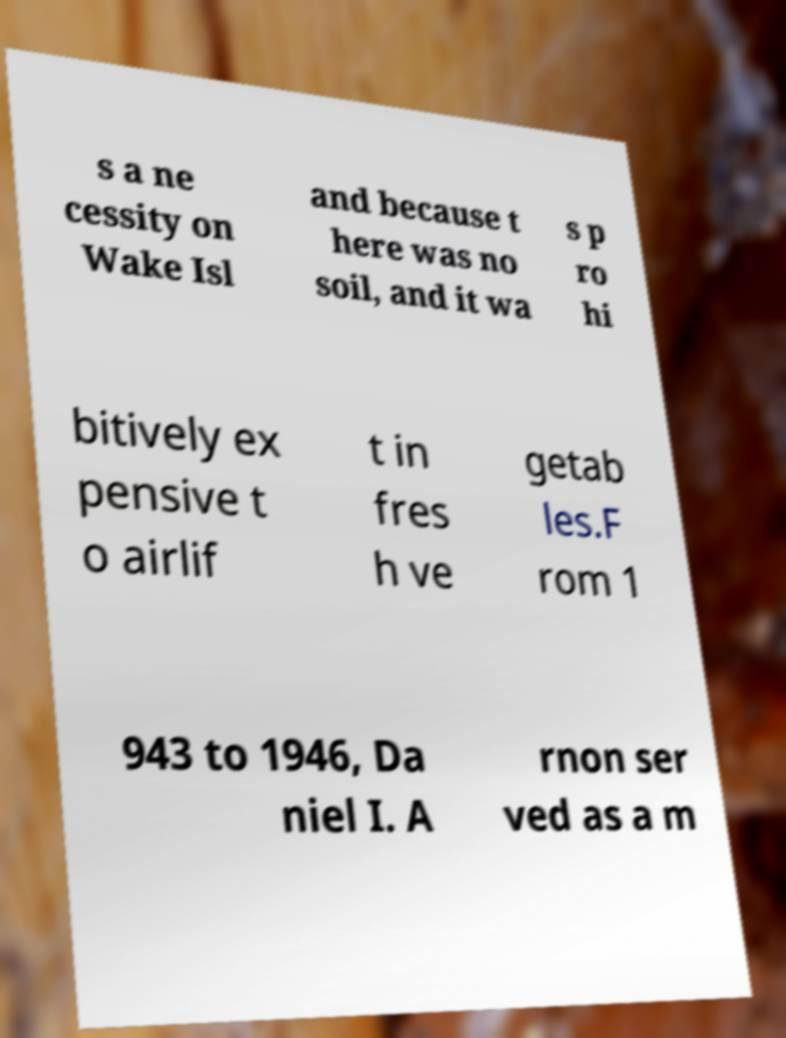For documentation purposes, I need the text within this image transcribed. Could you provide that? s a ne cessity on Wake Isl and because t here was no soil, and it wa s p ro hi bitively ex pensive t o airlif t in fres h ve getab les.F rom 1 943 to 1946, Da niel I. A rnon ser ved as a m 